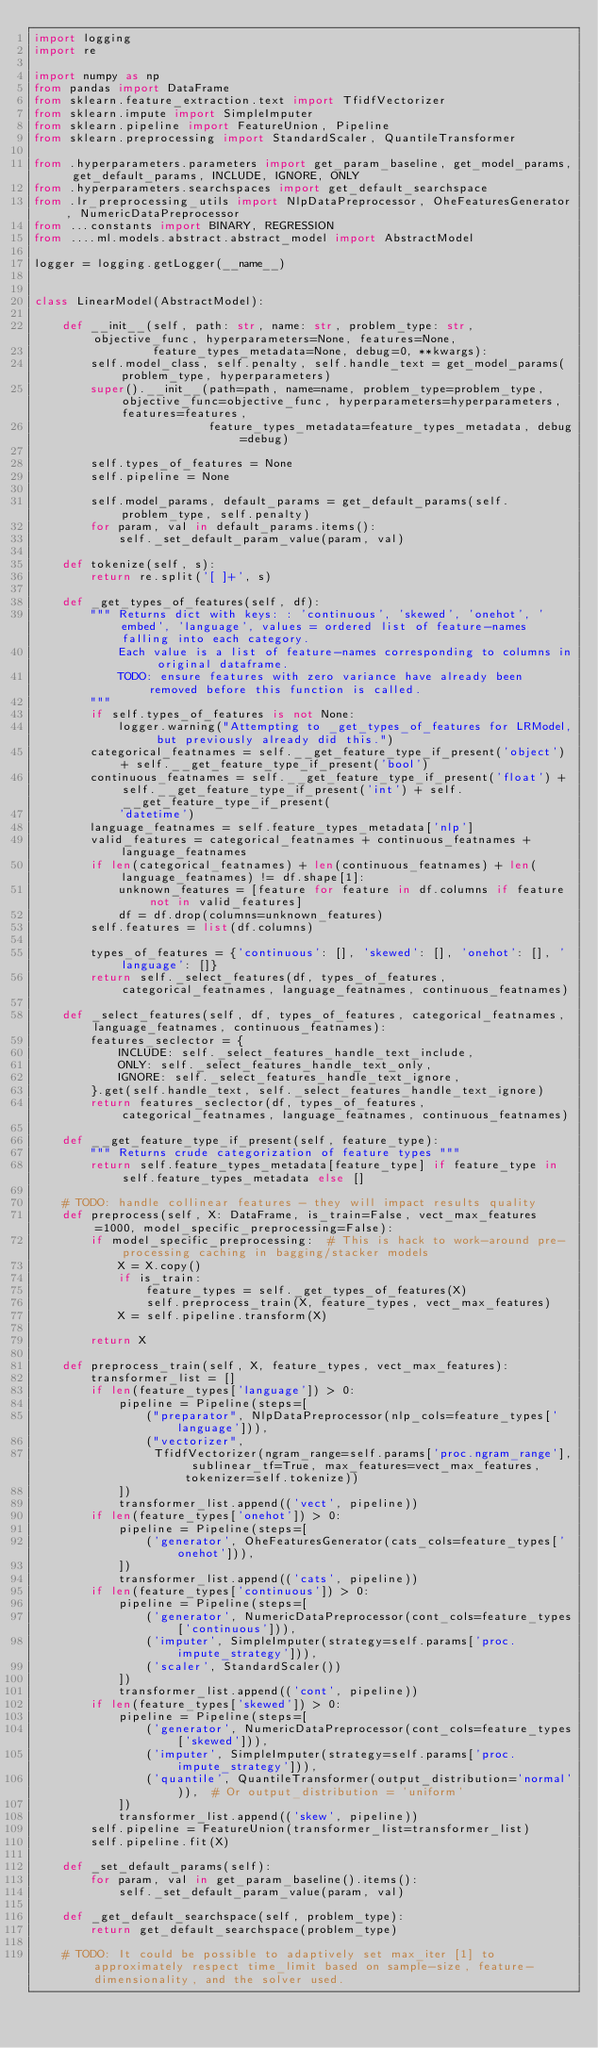Convert code to text. <code><loc_0><loc_0><loc_500><loc_500><_Python_>import logging
import re

import numpy as np
from pandas import DataFrame
from sklearn.feature_extraction.text import TfidfVectorizer
from sklearn.impute import SimpleImputer
from sklearn.pipeline import FeatureUnion, Pipeline
from sklearn.preprocessing import StandardScaler, QuantileTransformer

from .hyperparameters.parameters import get_param_baseline, get_model_params, get_default_params, INCLUDE, IGNORE, ONLY
from .hyperparameters.searchspaces import get_default_searchspace
from .lr_preprocessing_utils import NlpDataPreprocessor, OheFeaturesGenerator, NumericDataPreprocessor
from ...constants import BINARY, REGRESSION
from ....ml.models.abstract.abstract_model import AbstractModel

logger = logging.getLogger(__name__)


class LinearModel(AbstractModel):

    def __init__(self, path: str, name: str, problem_type: str, objective_func, hyperparameters=None, features=None,
                 feature_types_metadata=None, debug=0, **kwargs):
        self.model_class, self.penalty, self.handle_text = get_model_params(problem_type, hyperparameters)
        super().__init__(path=path, name=name, problem_type=problem_type, objective_func=objective_func, hyperparameters=hyperparameters, features=features,
                         feature_types_metadata=feature_types_metadata, debug=debug)

        self.types_of_features = None
        self.pipeline = None

        self.model_params, default_params = get_default_params(self.problem_type, self.penalty)
        for param, val in default_params.items():
            self._set_default_param_value(param, val)

    def tokenize(self, s):
        return re.split('[ ]+', s)

    def _get_types_of_features(self, df):
        """ Returns dict with keys: : 'continuous', 'skewed', 'onehot', 'embed', 'language', values = ordered list of feature-names falling into each category.
            Each value is a list of feature-names corresponding to columns in original dataframe.
            TODO: ensure features with zero variance have already been removed before this function is called.
        """
        if self.types_of_features is not None:
            logger.warning("Attempting to _get_types_of_features for LRModel, but previously already did this.")
        categorical_featnames = self.__get_feature_type_if_present('object') + self.__get_feature_type_if_present('bool')
        continuous_featnames = self.__get_feature_type_if_present('float') + self.__get_feature_type_if_present('int') + self.__get_feature_type_if_present(
            'datetime')
        language_featnames = self.feature_types_metadata['nlp']
        valid_features = categorical_featnames + continuous_featnames + language_featnames
        if len(categorical_featnames) + len(continuous_featnames) + len(language_featnames) != df.shape[1]:
            unknown_features = [feature for feature in df.columns if feature not in valid_features]
            df = df.drop(columns=unknown_features)
        self.features = list(df.columns)

        types_of_features = {'continuous': [], 'skewed': [], 'onehot': [], 'language': []}
        return self._select_features(df, types_of_features, categorical_featnames, language_featnames, continuous_featnames)

    def _select_features(self, df, types_of_features, categorical_featnames, language_featnames, continuous_featnames):
        features_seclector = {
            INCLUDE: self._select_features_handle_text_include,
            ONLY: self._select_features_handle_text_only,
            IGNORE: self._select_features_handle_text_ignore,
        }.get(self.handle_text, self._select_features_handle_text_ignore)
        return features_seclector(df, types_of_features, categorical_featnames, language_featnames, continuous_featnames)

    def __get_feature_type_if_present(self, feature_type):
        """ Returns crude categorization of feature types """
        return self.feature_types_metadata[feature_type] if feature_type in self.feature_types_metadata else []

    # TODO: handle collinear features - they will impact results quality
    def preprocess(self, X: DataFrame, is_train=False, vect_max_features=1000, model_specific_preprocessing=False):
        if model_specific_preprocessing:  # This is hack to work-around pre-processing caching in bagging/stacker models
            X = X.copy()
            if is_train:
                feature_types = self._get_types_of_features(X)
                self.preprocess_train(X, feature_types, vect_max_features)
            X = self.pipeline.transform(X)

        return X

    def preprocess_train(self, X, feature_types, vect_max_features):
        transformer_list = []
        if len(feature_types['language']) > 0:
            pipeline = Pipeline(steps=[
                ("preparator", NlpDataPreprocessor(nlp_cols=feature_types['language'])),
                ("vectorizer",
                 TfidfVectorizer(ngram_range=self.params['proc.ngram_range'], sublinear_tf=True, max_features=vect_max_features, tokenizer=self.tokenize))
            ])
            transformer_list.append(('vect', pipeline))
        if len(feature_types['onehot']) > 0:
            pipeline = Pipeline(steps=[
                ('generator', OheFeaturesGenerator(cats_cols=feature_types['onehot'])),
            ])
            transformer_list.append(('cats', pipeline))
        if len(feature_types['continuous']) > 0:
            pipeline = Pipeline(steps=[
                ('generator', NumericDataPreprocessor(cont_cols=feature_types['continuous'])),
                ('imputer', SimpleImputer(strategy=self.params['proc.impute_strategy'])),
                ('scaler', StandardScaler())
            ])
            transformer_list.append(('cont', pipeline))
        if len(feature_types['skewed']) > 0:
            pipeline = Pipeline(steps=[
                ('generator', NumericDataPreprocessor(cont_cols=feature_types['skewed'])),
                ('imputer', SimpleImputer(strategy=self.params['proc.impute_strategy'])),
                ('quantile', QuantileTransformer(output_distribution='normal')),  # Or output_distribution = 'uniform'
            ])
            transformer_list.append(('skew', pipeline))
        self.pipeline = FeatureUnion(transformer_list=transformer_list)
        self.pipeline.fit(X)

    def _set_default_params(self):
        for param, val in get_param_baseline().items():
            self._set_default_param_value(param, val)

    def _get_default_searchspace(self, problem_type):
        return get_default_searchspace(problem_type)

    # TODO: It could be possible to adaptively set max_iter [1] to approximately respect time_limit based on sample-size, feature-dimensionality, and the solver used.</code> 